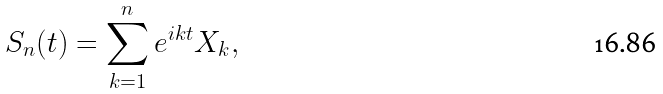<formula> <loc_0><loc_0><loc_500><loc_500>S _ { n } ( t ) = \sum _ { k = 1 } ^ { n } e ^ { i k t } X _ { k } ,</formula> 